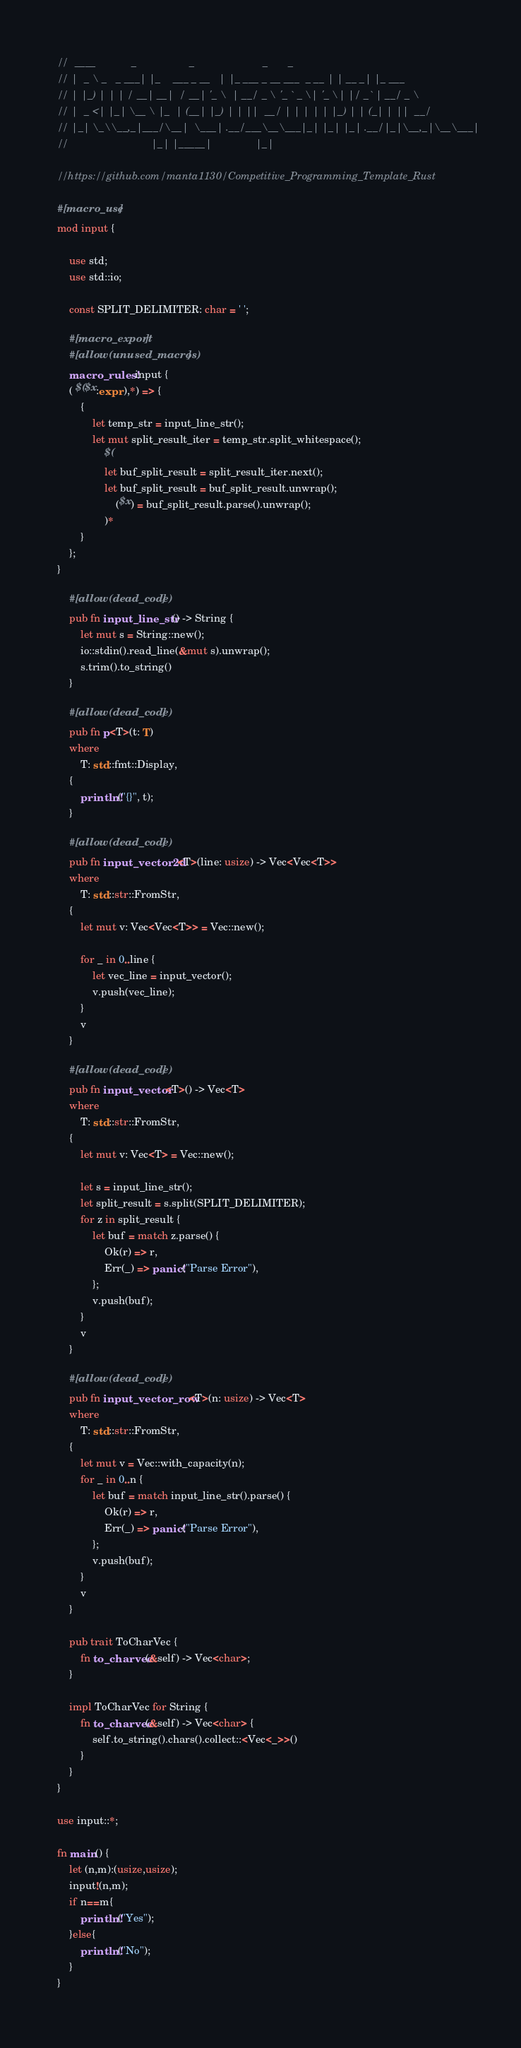Convert code to text. <code><loc_0><loc_0><loc_500><loc_500><_Rust_>//  ____            _                  _                       _       _
// |  _ \ _   _ ___| |_    ___ _ __   | |_ ___ _ __ ___  _ __ | | __ _| |_ ___
// | |_) | | | / __| __|  / __| '_ \  | __/ _ \ '_ ` _ \| '_ \| |/ _` | __/ _ \
// |  _ <| |_| \__ \ |_  | (__| |_) | | ||  __/ | | | | | |_) | | (_| | ||  __/
// |_| \_\\__,_|___/\__|  \___| .__/___\__\___|_| |_| |_| .__/|_|\__,_|\__\___|
//                            |_| |_____|               |_|

//https://github.com/manta1130/Competitive_Programming_Template_Rust

#[macro_use]
mod input {

    use std;
    use std::io;

    const SPLIT_DELIMITER: char = ' ';

    #[macro_export]
    #[allow(unused_macros)]
    macro_rules! input {
    ( $($x:expr ),*) => {
        {
            let temp_str = input_line_str();
            let mut split_result_iter = temp_str.split_whitespace();
                $(
                let buf_split_result = split_result_iter.next();
                let buf_split_result = buf_split_result.unwrap();
                    ($x) = buf_split_result.parse().unwrap();
                )*
        }
    };
}

    #[allow(dead_code)]
    pub fn input_line_str() -> String {
        let mut s = String::new();
        io::stdin().read_line(&mut s).unwrap();
        s.trim().to_string()
    }

    #[allow(dead_code)]
    pub fn p<T>(t: T)
    where
        T: std::fmt::Display,
    {
        println!("{}", t);
    }

    #[allow(dead_code)]
    pub fn input_vector2d<T>(line: usize) -> Vec<Vec<T>>
    where
        T: std::str::FromStr,
    {
        let mut v: Vec<Vec<T>> = Vec::new();

        for _ in 0..line {
            let vec_line = input_vector();
            v.push(vec_line);
        }
        v
    }

    #[allow(dead_code)]
    pub fn input_vector<T>() -> Vec<T>
    where
        T: std::str::FromStr,
    {
        let mut v: Vec<T> = Vec::new();

        let s = input_line_str();
        let split_result = s.split(SPLIT_DELIMITER);
        for z in split_result {
            let buf = match z.parse() {
                Ok(r) => r,
                Err(_) => panic!("Parse Error"),
            };
            v.push(buf);
        }
        v
    }

    #[allow(dead_code)]
    pub fn input_vector_row<T>(n: usize) -> Vec<T>
    where
        T: std::str::FromStr,
    {
        let mut v = Vec::with_capacity(n);
        for _ in 0..n {
            let buf = match input_line_str().parse() {
                Ok(r) => r,
                Err(_) => panic!("Parse Error"),
            };
            v.push(buf);
        }
        v
    }

    pub trait ToCharVec {
        fn to_charvec(&self) -> Vec<char>;
    }

    impl ToCharVec for String {
        fn to_charvec(&self) -> Vec<char> {
            self.to_string().chars().collect::<Vec<_>>()
        }
    }
}

use input::*;

fn main() {
    let (n,m):(usize,usize);
    input!(n,m);
    if n==m{
        println!("Yes");
    }else{
        println!("No");
    }
}
</code> 